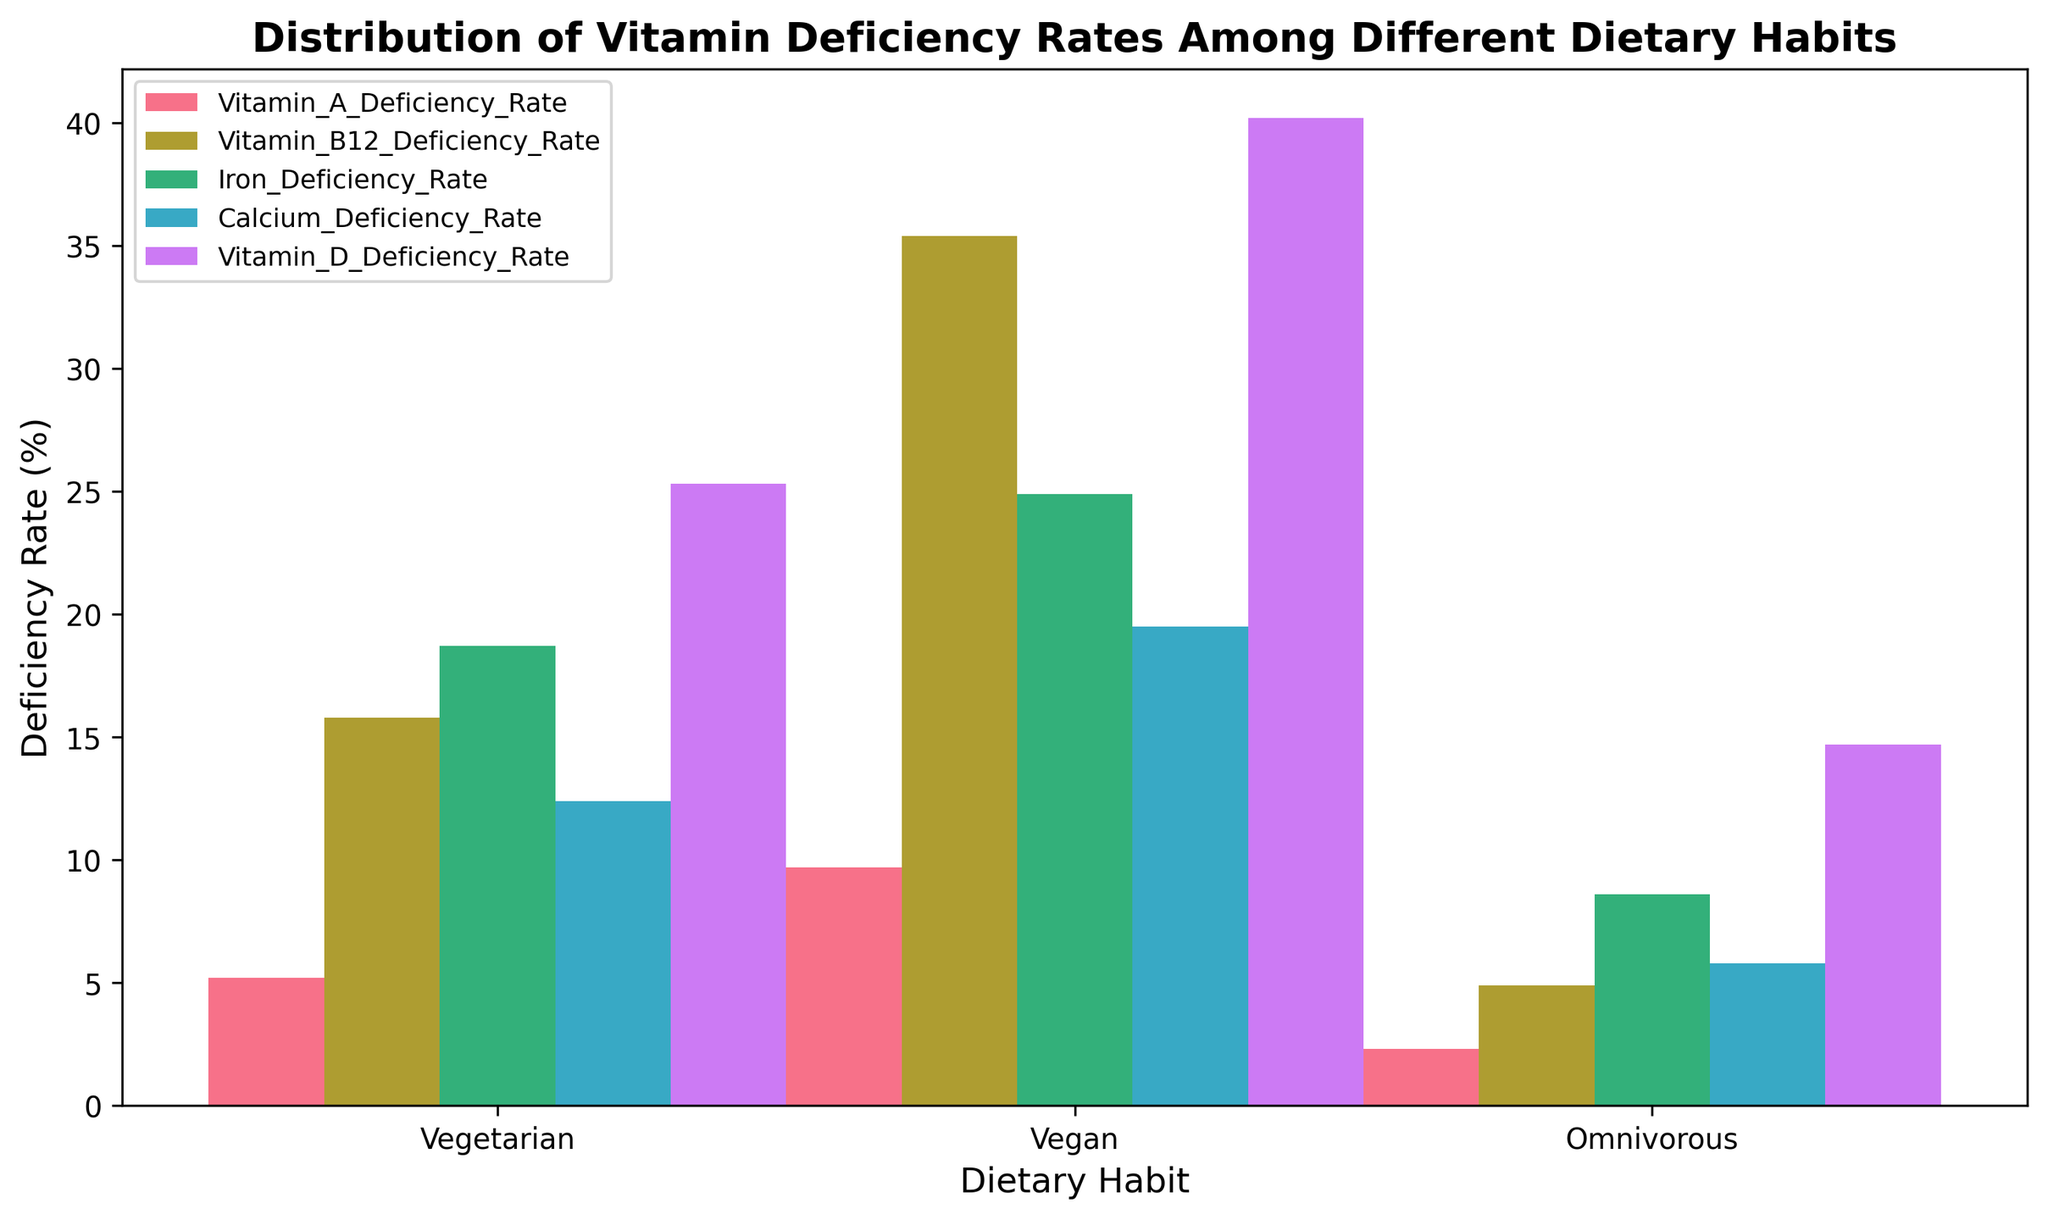What's the deficiency rate of Vitamin A among vegans? To find the deficiency rate of Vitamin A among vegans, locate the bar for "Vitamin_A_Deficiency_Rate" in the "Vegan" group on the x-axis. It shows a rate of 9.7%.
Answer: 9.7% How does the Vitamin B12 deficiency rate in vegetarians compare to that in omnivores? The Vitamin B12 deficiency rate for vegetarians is 15.8%. For omnivores, it is 4.9%. Comparing these values, the rate in vegetarians is higher.
Answer: The rate in vegetarians is higher What is the difference in Iron deficiency rates between vegetarians and vegans? Locate the Iron deficiency rates for both vegetarians and vegans. Vegetarians have a rate of 18.7% and vegans 24.9%. The difference is 24.9% - 18.7% = 6.2%.
Answer: 6.2% Which dietary habit has the highest Calcium deficiency rate? Compare the calcium deficiency rates among all dietary habits. Vegans have the highest rate at 19.5%.
Answer: Vegans What's the average deficiency rate of Vitamin D across all dietary habits? Calculate the average of Vitamin D deficiency rates: (25.3% + 40.2% + 14.7%) / 3. This sums up to 80.2% / 3 ≈ 26.73%.
Answer: 26.73% Is there any dietary habit with a Vitamin A deficiency rate greater than 6%? Check the Vitamin A deficiency rates. Vegans have a rate of 9.7%, which is greater than 6%.
Answer: Yes, vegans How much greater is the Vitamin D deficiency rate in vegans compared to omnivores? The Vitamin D deficiency rate for vegans is 40.2%, and for omnivores, it is 14.7%. The difference is 40.2% - 14.7% = 25.5%.
Answer: 25.5% Between vegetarians and vegans, which group has a higher average deficiency rate across all vitamins listed? First, calculate the average deficiency rates for both groups. For vegetarians: (5.2% + 15.8% + 18.7% + 12.4% + 25.3%) / 5 = 15.48%. For vegans: (9.7% + 35.4% + 24.9% + 19.5% + 40.2%) / 5 = 25.94%. Vegans have a higher average rate.
Answer: Vegans Which deficiency rate category stands out visually as having the tallest bars across all dietary habits? Observe the heights of the bars for each deficiency category. The Vitamin B12 deficiency rate generally shows the tallest bars.
Answer: Vitamin B12 deficiency rate 